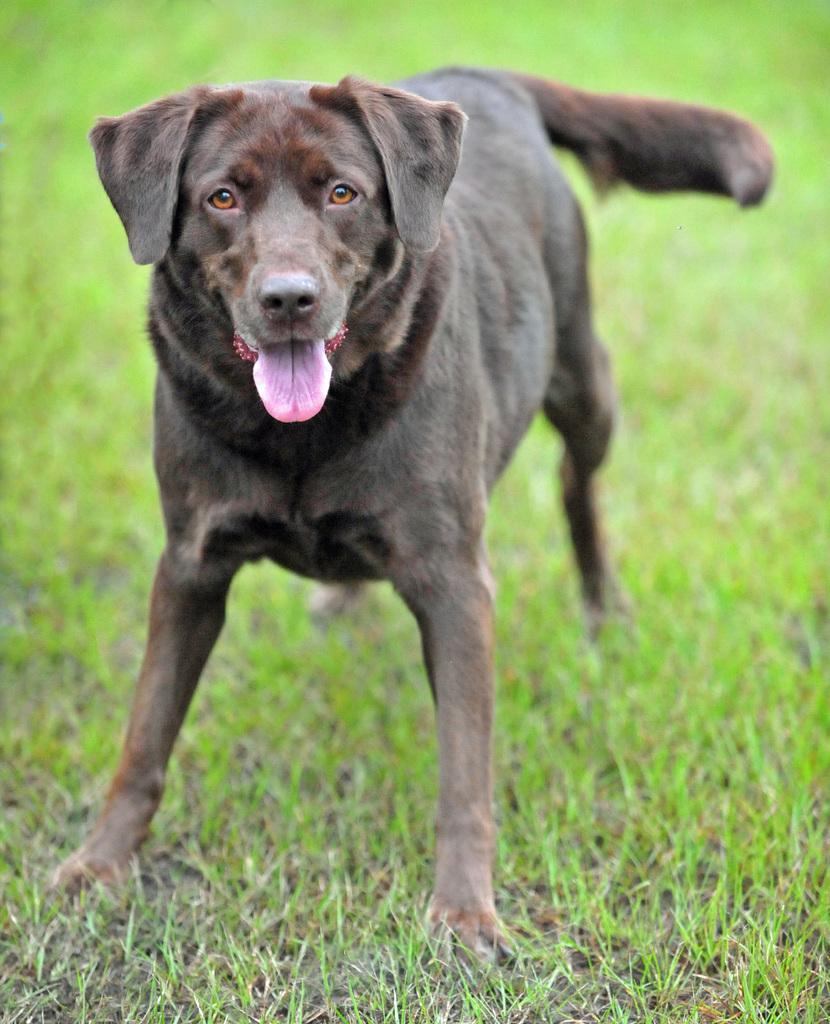Can you describe this image briefly? In this picture there is a dog in the center of the image on the grassland. 